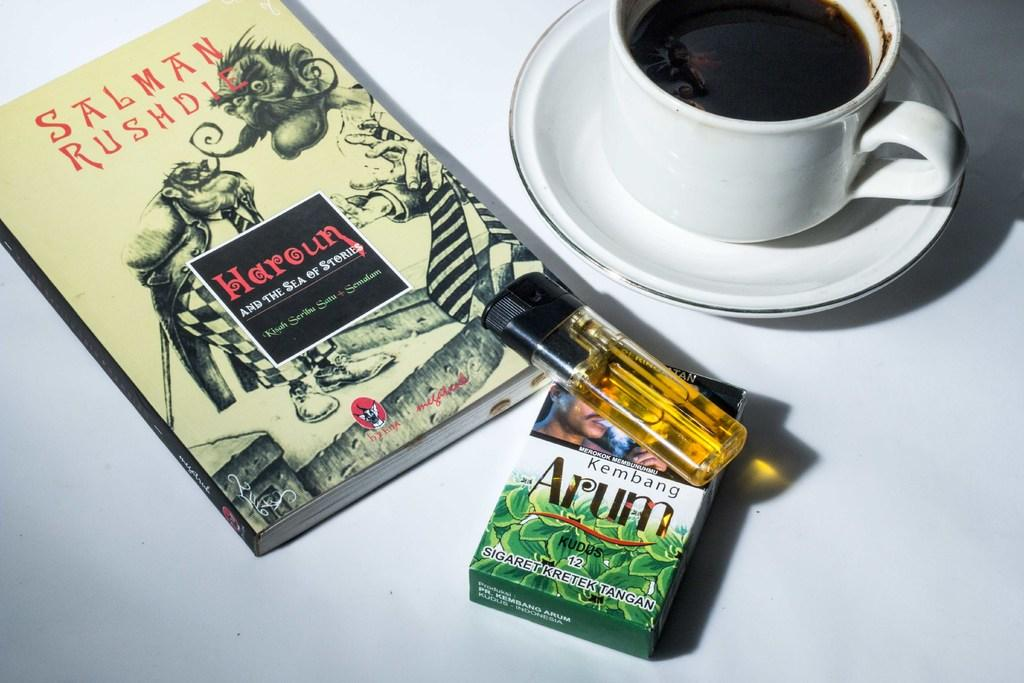<image>
Create a compact narrative representing the image presented. A book by Salman Rushdie features strange cartoon figures on the cover. 